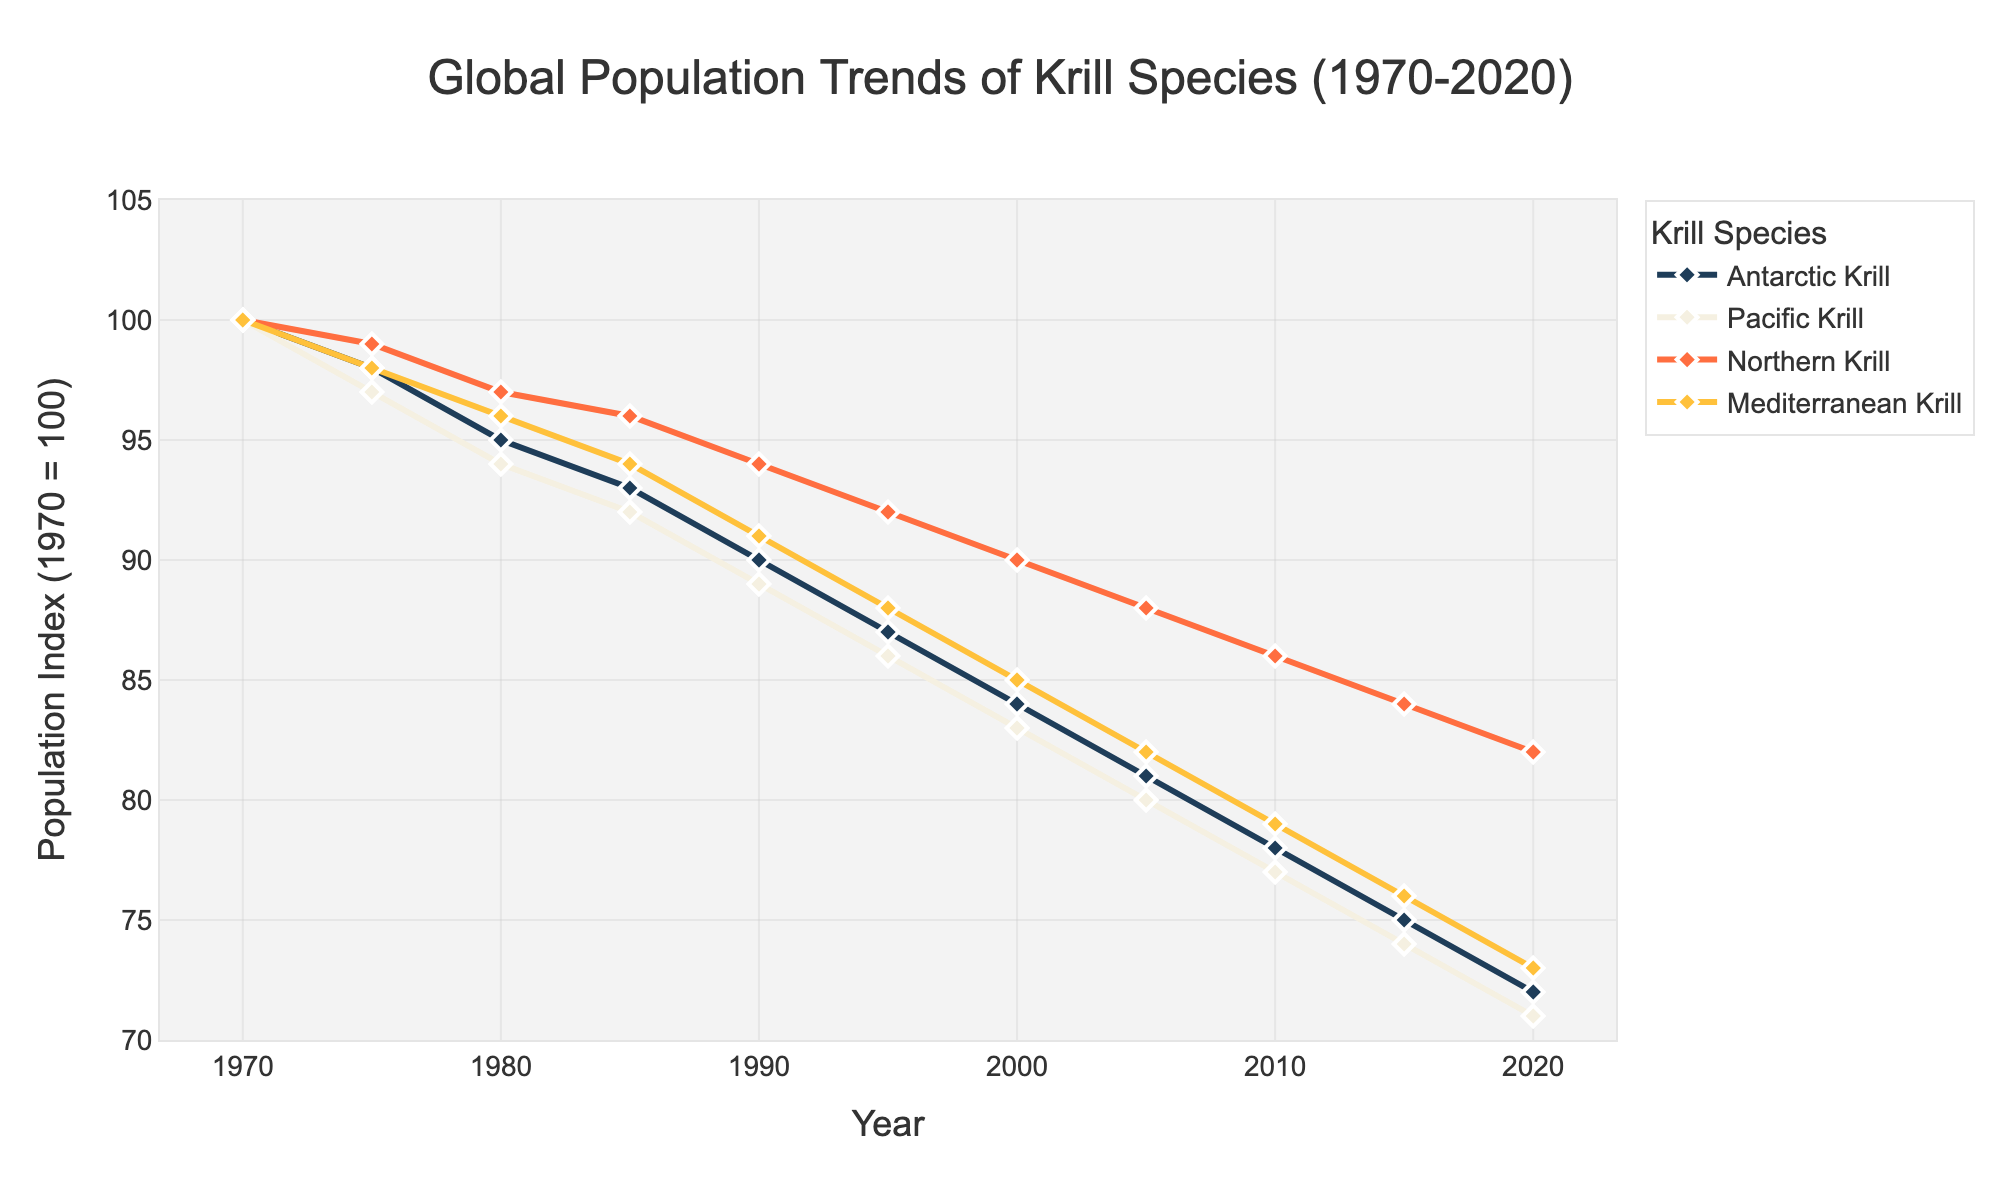What was the global population index of Antarctic Krill in 1990? Look at the data point for Antarctic Krill in the year 1990, which is directly taken from the y-axis value for that year.
Answer: 90 Which krill species had the largest decrease in population index from 1970 to 2020? Calculate the difference in population index from 1970 to 2020 for each species: 
Antarctic Krill: 100 - 72 = 28 
Pacific Krill: 100 - 71 = 29 
Northern Krill: 100 - 82 = 18 
Mediterranean Krill: 100 - 73 = 27 
Pacific Krill had the largest decrease.
Answer: Pacific Krill What is the average population index of Mediterranean Krill across all the years shown? Sum up the population indices of Mediterranean Krill for every year and divide by the number of years. 
(100+98+96+94+91+88+85+82+79+76+73) / 11 
= 962 / 11 = 87.45
Answer: 87.45 How does the population index of Northern Krill in 2000 compare to that of Pacific Krill in 2000? Check the data points for both species in the year 2000 from the y-axis values: Northern Krill: 90, Pacific Krill: 83.
Answer: Northern Krill has a higher population index than Pacific Krill in 2000 By how much did the population index of Antarctic Krill decline from 1985 to 2015? Find the population indices for Antarctic Krill in 1985 and 2015 and calculate the difference: 
1985 = 93, 2015 = 75 
93 - 75 = 18
Answer: By 18 In which year did the population index of Pacific Krill fall below 80? Identify the year where the population index of Pacific Krill first dips below 80. According to the data points, it happens in 2020.
Answer: 2020 What can be inferred about the trend in population indices for all krill species from 1970 to 2020? Observe that the population indices for all krill species show a downward trend over the years. Each species' population index declines from 100 in 1970 to lower values in 2020.
Answer: All declined By what percentage did the population index of Mediterranean Krill decrease from 1970 to 2005? Perform the percentage decrease calculation: 
((100 - 82) / 100) * 100 = 18%
Answer: 18% 